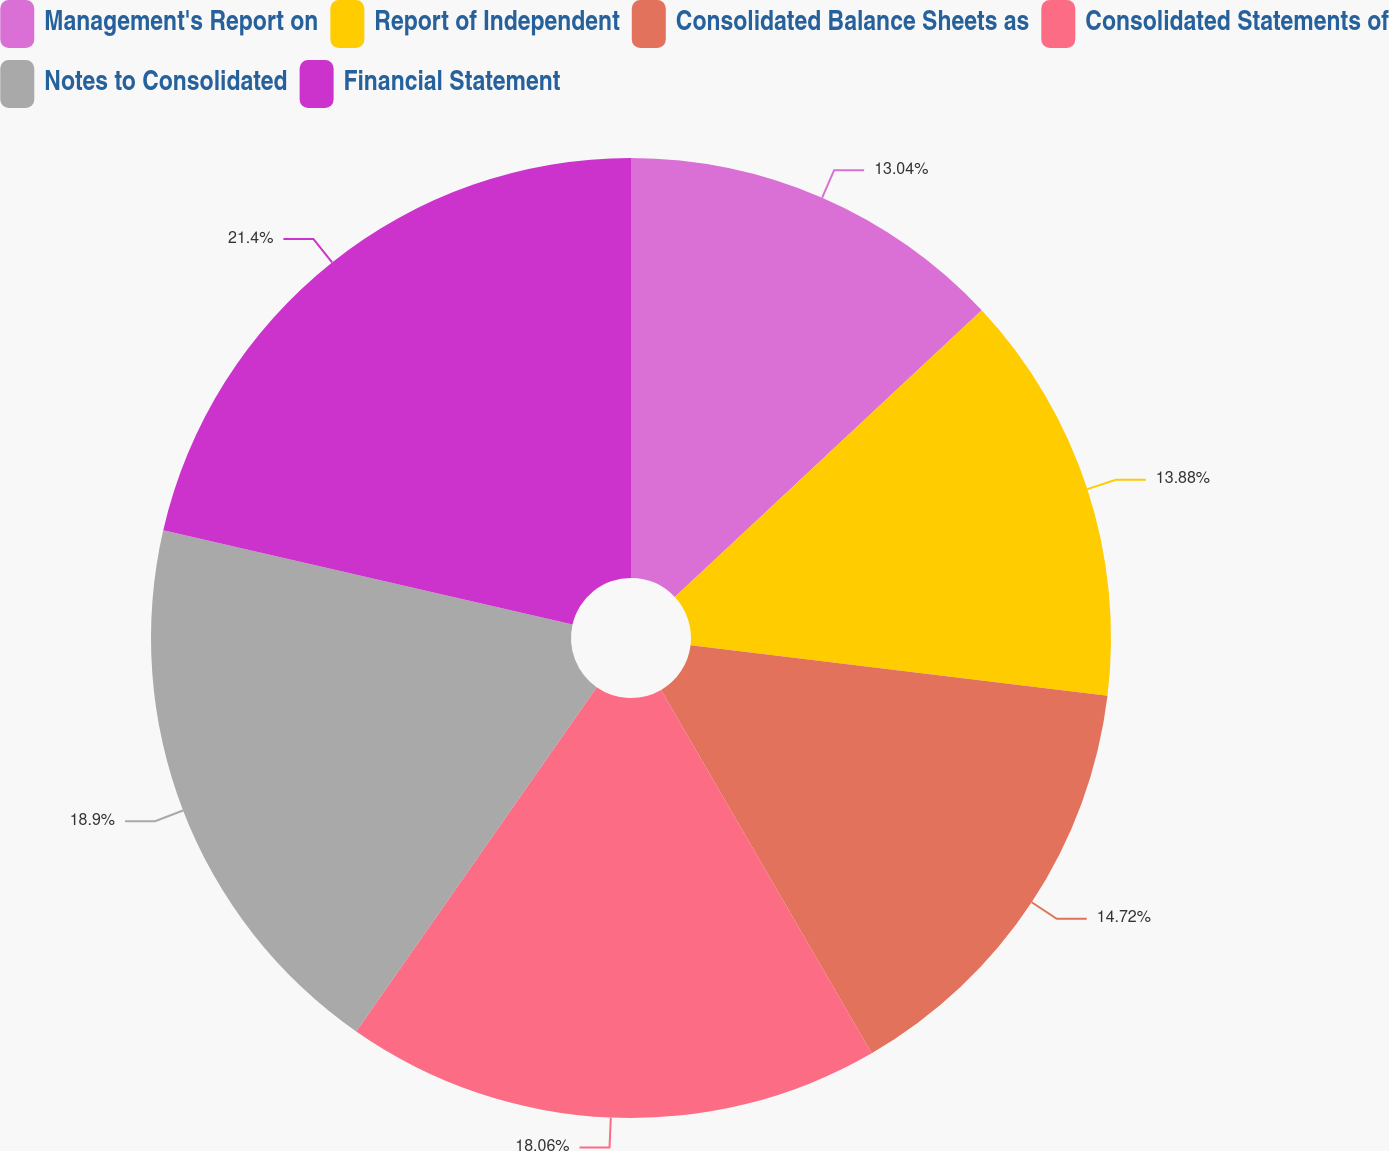Convert chart. <chart><loc_0><loc_0><loc_500><loc_500><pie_chart><fcel>Management's Report on<fcel>Report of Independent<fcel>Consolidated Balance Sheets as<fcel>Consolidated Statements of<fcel>Notes to Consolidated<fcel>Financial Statement<nl><fcel>13.04%<fcel>13.88%<fcel>14.72%<fcel>18.06%<fcel>18.9%<fcel>21.4%<nl></chart> 